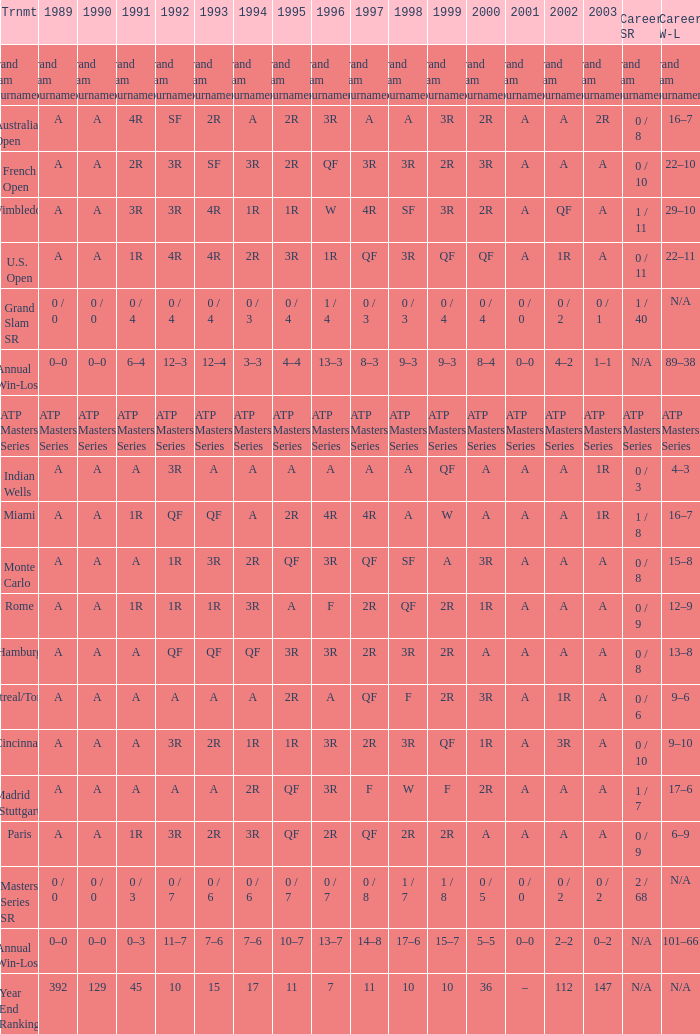What was the value in 1989 with QF in 1997 and A in 1993? A. 